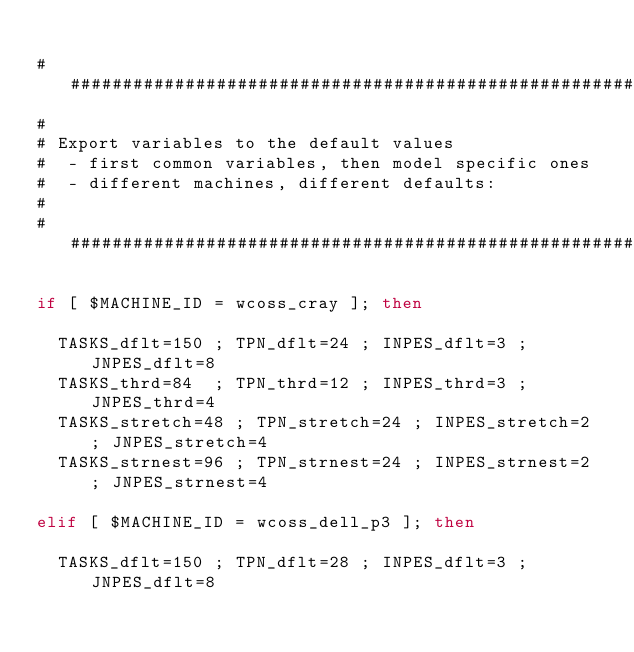<code> <loc_0><loc_0><loc_500><loc_500><_Bash_>
###############################################################################
#
# Export variables to the default values
#  - first common variables, then model specific ones
#  - different machines, different defaults:
#
###############################################################################

if [ $MACHINE_ID = wcoss_cray ]; then

  TASKS_dflt=150 ; TPN_dflt=24 ; INPES_dflt=3 ; JNPES_dflt=8
  TASKS_thrd=84  ; TPN_thrd=12 ; INPES_thrd=3 ; JNPES_thrd=4
  TASKS_stretch=48 ; TPN_stretch=24 ; INPES_stretch=2 ; JNPES_stretch=4
  TASKS_strnest=96 ; TPN_strnest=24 ; INPES_strnest=2 ; JNPES_strnest=4

elif [ $MACHINE_ID = wcoss_dell_p3 ]; then

  TASKS_dflt=150 ; TPN_dflt=28 ; INPES_dflt=3 ; JNPES_dflt=8</code> 